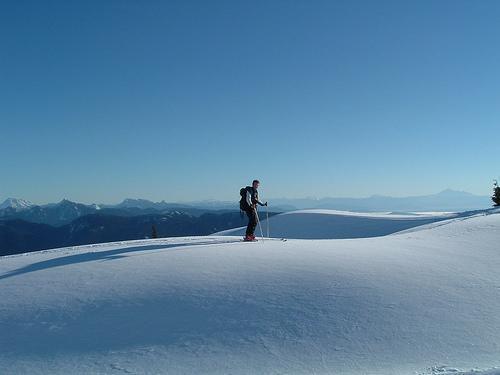How many ski poles is the man  holding?
Give a very brief answer. 2. How many trees have leaves?
Give a very brief answer. 0. How many people are riding bikes?
Give a very brief answer. 0. 